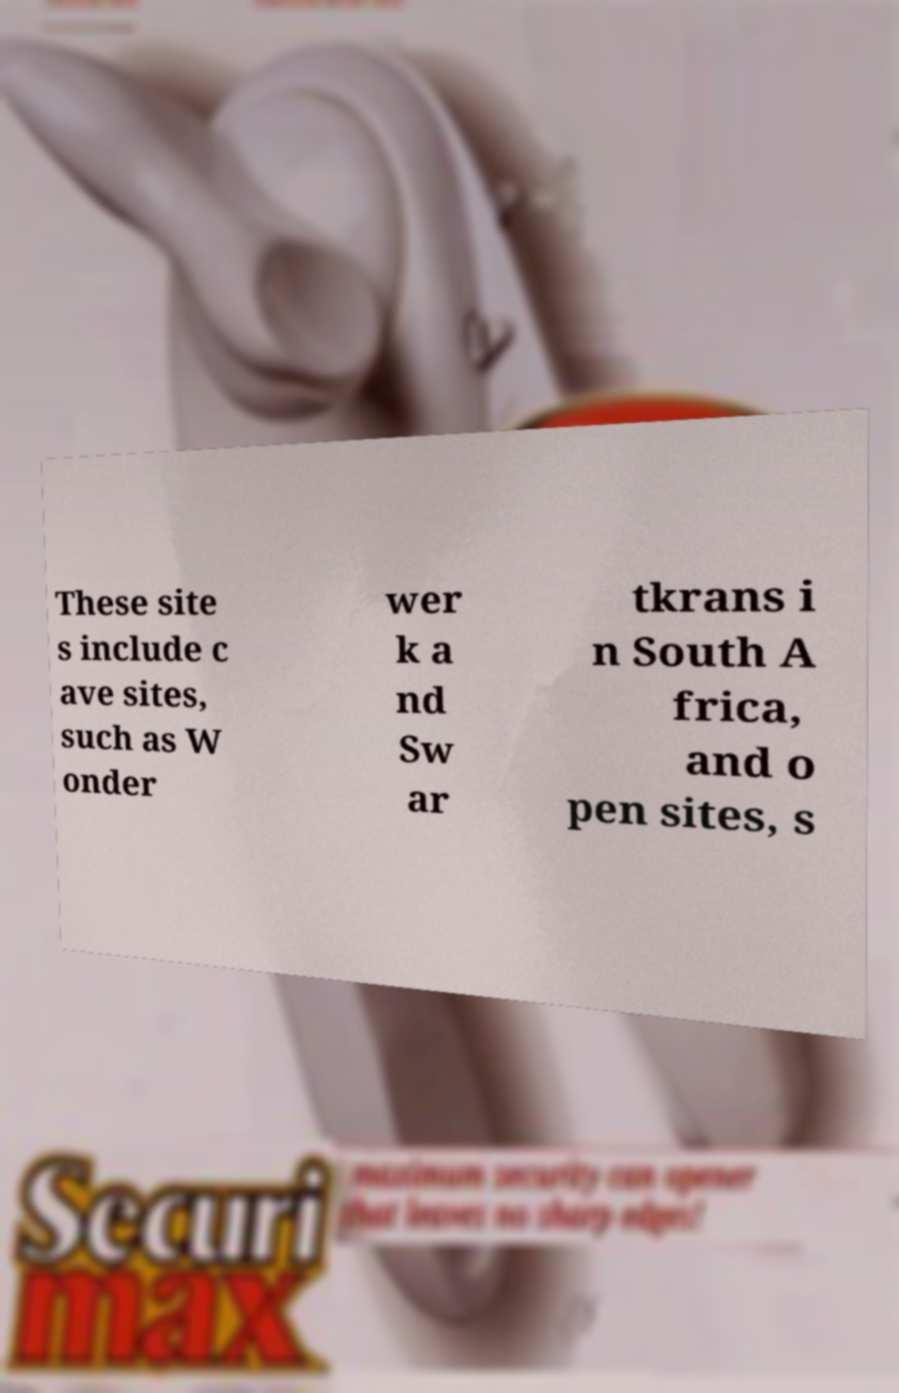Please read and relay the text visible in this image. What does it say? These site s include c ave sites, such as W onder wer k a nd Sw ar tkrans i n South A frica, and o pen sites, s 